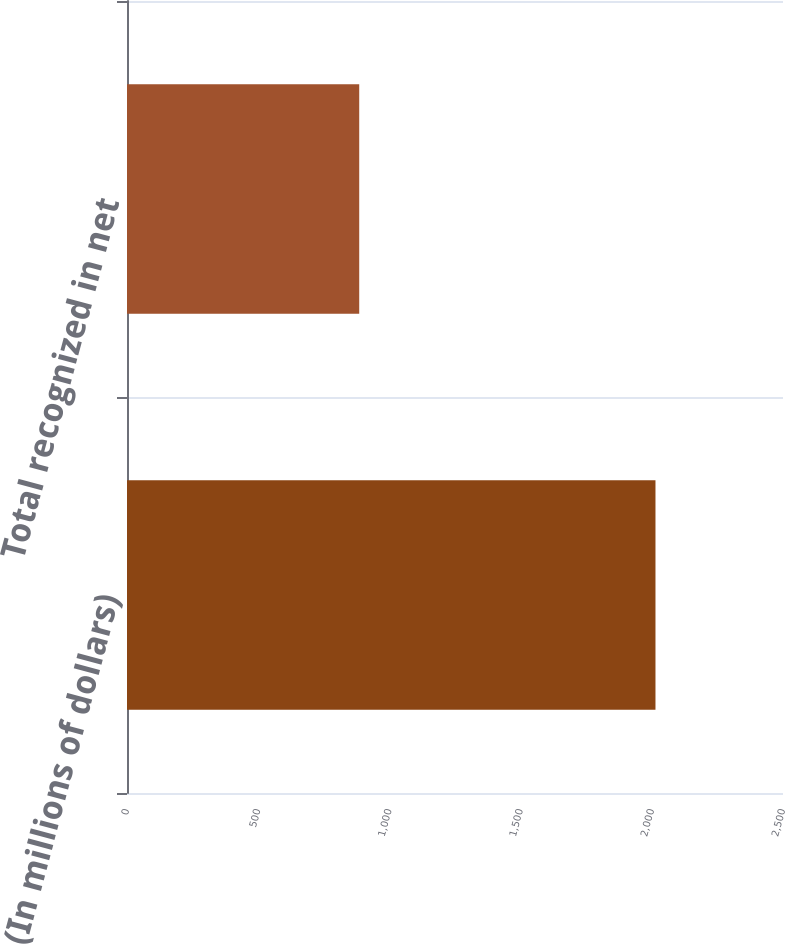<chart> <loc_0><loc_0><loc_500><loc_500><bar_chart><fcel>(In millions of dollars)<fcel>Total recognized in net<nl><fcel>2014<fcel>885<nl></chart> 